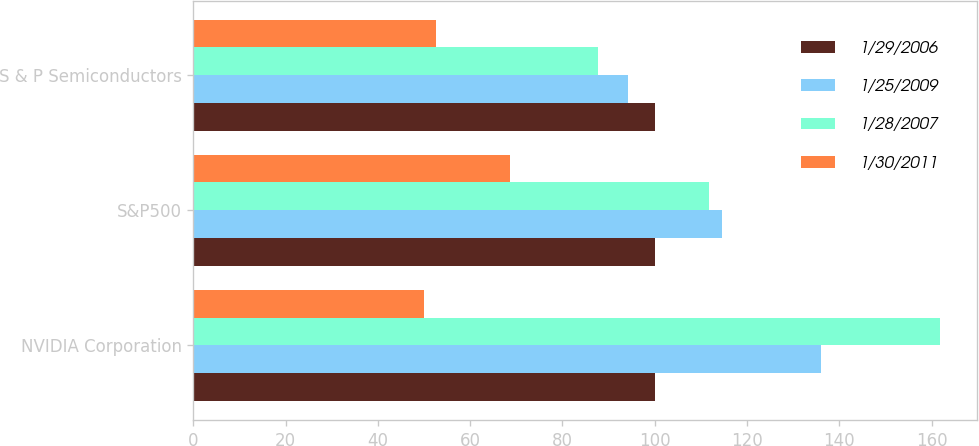Convert chart. <chart><loc_0><loc_0><loc_500><loc_500><stacked_bar_chart><ecel><fcel>NVIDIA Corporation<fcel>S&P500<fcel>S & P Semiconductors<nl><fcel>1/29/2006<fcel>100<fcel>100<fcel>100<nl><fcel>1/25/2009<fcel>136.09<fcel>114.51<fcel>94.16<nl><fcel>1/28/2007<fcel>161.84<fcel>111.87<fcel>87.75<nl><fcel>1/30/2011<fcel>50.01<fcel>68.66<fcel>52.6<nl></chart> 